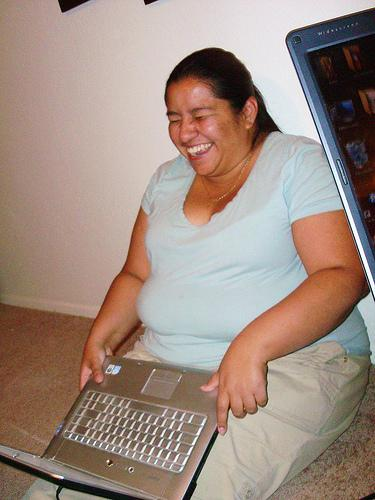Mention the primary individual in the image and their activity. A woman with brown hair, wearing a light blue shirt, is sitting on a beige carpeted floor, holding a silver laptop in her lap and smiling. Quickly summarize the key person in the image and their main action. Woman with brown hair sits on carpet, holding silver laptop, and laughing. In one sentence, describe the main person in the image and what they are doing. The image shows a woman with brown hair sitting on a beige carpet, holding a silver laptop, laughing, and enjoying herself. Identify the central character in the image and their current activity. The central character is a woman with dark hair, sitting on a carpet, holding a silver laptop, and laughing joyfully. Write a brief sentence about the central person in the picture and their action. A slightly overweight woman with dark hair is sitting on the floor, laughing and holding a silver laptop. What is the main focus of the image and what are they engaged in? The image focuses on a woman with dark-colored hair who is sitting on a tan carpet, holding a gray laptop, and laughing. Write a concise description of the primary person in the picture and their involvement. A woman with dark hair is seated on a light brown floor, holding a gray laptop, and laughing in a jovial manner. Describe the primary figure in the image and their engagement. The primary figure is an overweight woman with dark hair, sitting on a tan carpet, holding a silver laptop, and smiling with her eyes closed. Who is the prominent figure in the picture and what are they occupied with? The prominent figure is a woman with dark hair, sitting on a light brown floor, holding a silver laptop, and happily laughing. State the subject of the image and what they appear to be doing. The subject of the image is a woman with brown hair, who is sitting on a beige floor, holding a silver-colored laptop, and smiling. 